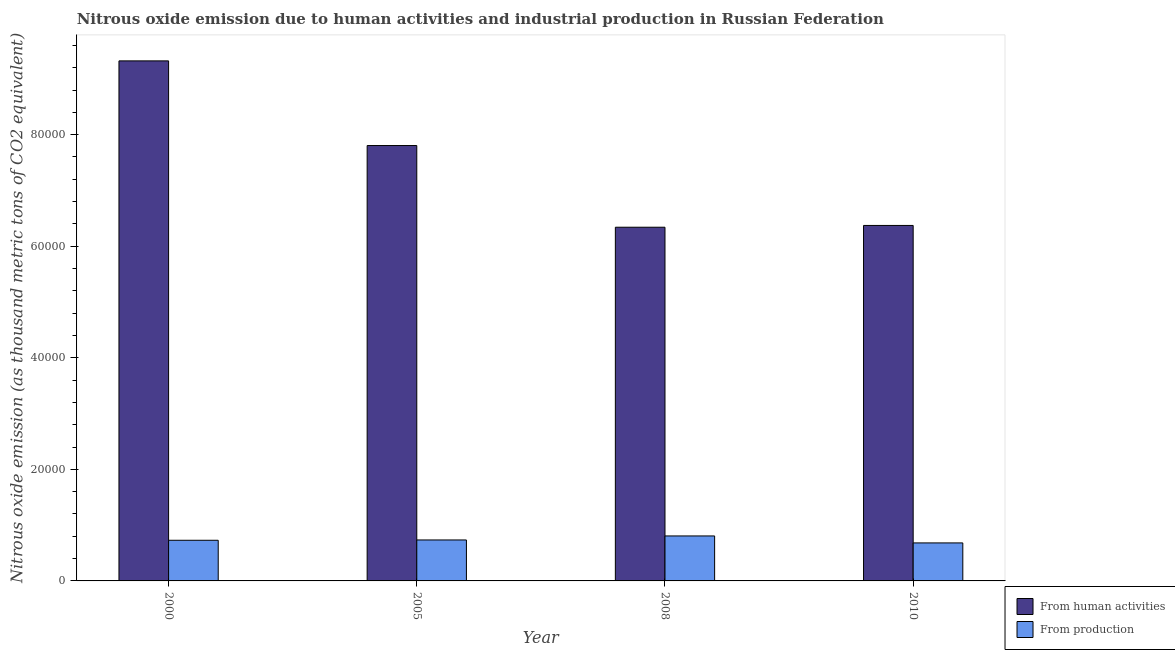How many different coloured bars are there?
Your answer should be very brief. 2. How many groups of bars are there?
Provide a short and direct response. 4. Are the number of bars per tick equal to the number of legend labels?
Provide a short and direct response. Yes. How many bars are there on the 4th tick from the left?
Offer a very short reply. 2. How many bars are there on the 3rd tick from the right?
Ensure brevity in your answer.  2. In how many cases, is the number of bars for a given year not equal to the number of legend labels?
Provide a succinct answer. 0. What is the amount of emissions from human activities in 2005?
Offer a very short reply. 7.81e+04. Across all years, what is the maximum amount of emissions generated from industries?
Give a very brief answer. 8062.7. Across all years, what is the minimum amount of emissions generated from industries?
Offer a very short reply. 6812.8. In which year was the amount of emissions from human activities minimum?
Make the answer very short. 2008. What is the total amount of emissions from human activities in the graph?
Your answer should be very brief. 2.98e+05. What is the difference between the amount of emissions from human activities in 2008 and that in 2010?
Provide a short and direct response. -319.3. What is the difference between the amount of emissions from human activities in 2008 and the amount of emissions generated from industries in 2010?
Offer a terse response. -319.3. What is the average amount of emissions from human activities per year?
Keep it short and to the point. 7.46e+04. In the year 2005, what is the difference between the amount of emissions generated from industries and amount of emissions from human activities?
Your response must be concise. 0. In how many years, is the amount of emissions generated from industries greater than 20000 thousand metric tons?
Your answer should be very brief. 0. What is the ratio of the amount of emissions generated from industries in 2008 to that in 2010?
Your response must be concise. 1.18. Is the amount of emissions from human activities in 2005 less than that in 2008?
Your answer should be compact. No. Is the difference between the amount of emissions from human activities in 2000 and 2008 greater than the difference between the amount of emissions generated from industries in 2000 and 2008?
Make the answer very short. No. What is the difference between the highest and the second highest amount of emissions generated from industries?
Give a very brief answer. 718.6. What is the difference between the highest and the lowest amount of emissions generated from industries?
Your answer should be very brief. 1249.9. In how many years, is the amount of emissions from human activities greater than the average amount of emissions from human activities taken over all years?
Ensure brevity in your answer.  2. Is the sum of the amount of emissions from human activities in 2005 and 2010 greater than the maximum amount of emissions generated from industries across all years?
Your response must be concise. Yes. What does the 1st bar from the left in 2005 represents?
Give a very brief answer. From human activities. What does the 2nd bar from the right in 2010 represents?
Your response must be concise. From human activities. How many bars are there?
Offer a terse response. 8. Are all the bars in the graph horizontal?
Provide a succinct answer. No. How many years are there in the graph?
Offer a very short reply. 4. Are the values on the major ticks of Y-axis written in scientific E-notation?
Your answer should be compact. No. Does the graph contain any zero values?
Your response must be concise. No. How are the legend labels stacked?
Give a very brief answer. Vertical. What is the title of the graph?
Offer a very short reply. Nitrous oxide emission due to human activities and industrial production in Russian Federation. What is the label or title of the X-axis?
Ensure brevity in your answer.  Year. What is the label or title of the Y-axis?
Provide a succinct answer. Nitrous oxide emission (as thousand metric tons of CO2 equivalent). What is the Nitrous oxide emission (as thousand metric tons of CO2 equivalent) of From human activities in 2000?
Provide a succinct answer. 9.32e+04. What is the Nitrous oxide emission (as thousand metric tons of CO2 equivalent) in From production in 2000?
Offer a very short reply. 7288.4. What is the Nitrous oxide emission (as thousand metric tons of CO2 equivalent) in From human activities in 2005?
Provide a succinct answer. 7.81e+04. What is the Nitrous oxide emission (as thousand metric tons of CO2 equivalent) in From production in 2005?
Offer a very short reply. 7344.1. What is the Nitrous oxide emission (as thousand metric tons of CO2 equivalent) in From human activities in 2008?
Make the answer very short. 6.34e+04. What is the Nitrous oxide emission (as thousand metric tons of CO2 equivalent) in From production in 2008?
Ensure brevity in your answer.  8062.7. What is the Nitrous oxide emission (as thousand metric tons of CO2 equivalent) in From human activities in 2010?
Provide a short and direct response. 6.37e+04. What is the Nitrous oxide emission (as thousand metric tons of CO2 equivalent) in From production in 2010?
Your response must be concise. 6812.8. Across all years, what is the maximum Nitrous oxide emission (as thousand metric tons of CO2 equivalent) of From human activities?
Provide a short and direct response. 9.32e+04. Across all years, what is the maximum Nitrous oxide emission (as thousand metric tons of CO2 equivalent) in From production?
Make the answer very short. 8062.7. Across all years, what is the minimum Nitrous oxide emission (as thousand metric tons of CO2 equivalent) of From human activities?
Ensure brevity in your answer.  6.34e+04. Across all years, what is the minimum Nitrous oxide emission (as thousand metric tons of CO2 equivalent) of From production?
Provide a short and direct response. 6812.8. What is the total Nitrous oxide emission (as thousand metric tons of CO2 equivalent) of From human activities in the graph?
Offer a terse response. 2.98e+05. What is the total Nitrous oxide emission (as thousand metric tons of CO2 equivalent) of From production in the graph?
Make the answer very short. 2.95e+04. What is the difference between the Nitrous oxide emission (as thousand metric tons of CO2 equivalent) in From human activities in 2000 and that in 2005?
Ensure brevity in your answer.  1.52e+04. What is the difference between the Nitrous oxide emission (as thousand metric tons of CO2 equivalent) of From production in 2000 and that in 2005?
Offer a terse response. -55.7. What is the difference between the Nitrous oxide emission (as thousand metric tons of CO2 equivalent) of From human activities in 2000 and that in 2008?
Offer a very short reply. 2.98e+04. What is the difference between the Nitrous oxide emission (as thousand metric tons of CO2 equivalent) of From production in 2000 and that in 2008?
Your response must be concise. -774.3. What is the difference between the Nitrous oxide emission (as thousand metric tons of CO2 equivalent) of From human activities in 2000 and that in 2010?
Your answer should be compact. 2.95e+04. What is the difference between the Nitrous oxide emission (as thousand metric tons of CO2 equivalent) in From production in 2000 and that in 2010?
Offer a very short reply. 475.6. What is the difference between the Nitrous oxide emission (as thousand metric tons of CO2 equivalent) in From human activities in 2005 and that in 2008?
Give a very brief answer. 1.46e+04. What is the difference between the Nitrous oxide emission (as thousand metric tons of CO2 equivalent) in From production in 2005 and that in 2008?
Ensure brevity in your answer.  -718.6. What is the difference between the Nitrous oxide emission (as thousand metric tons of CO2 equivalent) of From human activities in 2005 and that in 2010?
Keep it short and to the point. 1.43e+04. What is the difference between the Nitrous oxide emission (as thousand metric tons of CO2 equivalent) of From production in 2005 and that in 2010?
Provide a succinct answer. 531.3. What is the difference between the Nitrous oxide emission (as thousand metric tons of CO2 equivalent) in From human activities in 2008 and that in 2010?
Your response must be concise. -319.3. What is the difference between the Nitrous oxide emission (as thousand metric tons of CO2 equivalent) of From production in 2008 and that in 2010?
Offer a very short reply. 1249.9. What is the difference between the Nitrous oxide emission (as thousand metric tons of CO2 equivalent) in From human activities in 2000 and the Nitrous oxide emission (as thousand metric tons of CO2 equivalent) in From production in 2005?
Ensure brevity in your answer.  8.59e+04. What is the difference between the Nitrous oxide emission (as thousand metric tons of CO2 equivalent) of From human activities in 2000 and the Nitrous oxide emission (as thousand metric tons of CO2 equivalent) of From production in 2008?
Give a very brief answer. 8.52e+04. What is the difference between the Nitrous oxide emission (as thousand metric tons of CO2 equivalent) of From human activities in 2000 and the Nitrous oxide emission (as thousand metric tons of CO2 equivalent) of From production in 2010?
Provide a short and direct response. 8.64e+04. What is the difference between the Nitrous oxide emission (as thousand metric tons of CO2 equivalent) of From human activities in 2005 and the Nitrous oxide emission (as thousand metric tons of CO2 equivalent) of From production in 2008?
Give a very brief answer. 7.00e+04. What is the difference between the Nitrous oxide emission (as thousand metric tons of CO2 equivalent) in From human activities in 2005 and the Nitrous oxide emission (as thousand metric tons of CO2 equivalent) in From production in 2010?
Offer a very short reply. 7.12e+04. What is the difference between the Nitrous oxide emission (as thousand metric tons of CO2 equivalent) of From human activities in 2008 and the Nitrous oxide emission (as thousand metric tons of CO2 equivalent) of From production in 2010?
Your response must be concise. 5.66e+04. What is the average Nitrous oxide emission (as thousand metric tons of CO2 equivalent) of From human activities per year?
Ensure brevity in your answer.  7.46e+04. What is the average Nitrous oxide emission (as thousand metric tons of CO2 equivalent) in From production per year?
Your answer should be compact. 7377. In the year 2000, what is the difference between the Nitrous oxide emission (as thousand metric tons of CO2 equivalent) of From human activities and Nitrous oxide emission (as thousand metric tons of CO2 equivalent) of From production?
Offer a very short reply. 8.59e+04. In the year 2005, what is the difference between the Nitrous oxide emission (as thousand metric tons of CO2 equivalent) in From human activities and Nitrous oxide emission (as thousand metric tons of CO2 equivalent) in From production?
Offer a very short reply. 7.07e+04. In the year 2008, what is the difference between the Nitrous oxide emission (as thousand metric tons of CO2 equivalent) in From human activities and Nitrous oxide emission (as thousand metric tons of CO2 equivalent) in From production?
Your answer should be compact. 5.53e+04. In the year 2010, what is the difference between the Nitrous oxide emission (as thousand metric tons of CO2 equivalent) of From human activities and Nitrous oxide emission (as thousand metric tons of CO2 equivalent) of From production?
Keep it short and to the point. 5.69e+04. What is the ratio of the Nitrous oxide emission (as thousand metric tons of CO2 equivalent) in From human activities in 2000 to that in 2005?
Provide a short and direct response. 1.19. What is the ratio of the Nitrous oxide emission (as thousand metric tons of CO2 equivalent) in From production in 2000 to that in 2005?
Offer a terse response. 0.99. What is the ratio of the Nitrous oxide emission (as thousand metric tons of CO2 equivalent) of From human activities in 2000 to that in 2008?
Your answer should be compact. 1.47. What is the ratio of the Nitrous oxide emission (as thousand metric tons of CO2 equivalent) in From production in 2000 to that in 2008?
Offer a terse response. 0.9. What is the ratio of the Nitrous oxide emission (as thousand metric tons of CO2 equivalent) in From human activities in 2000 to that in 2010?
Your answer should be compact. 1.46. What is the ratio of the Nitrous oxide emission (as thousand metric tons of CO2 equivalent) in From production in 2000 to that in 2010?
Provide a succinct answer. 1.07. What is the ratio of the Nitrous oxide emission (as thousand metric tons of CO2 equivalent) of From human activities in 2005 to that in 2008?
Make the answer very short. 1.23. What is the ratio of the Nitrous oxide emission (as thousand metric tons of CO2 equivalent) of From production in 2005 to that in 2008?
Make the answer very short. 0.91. What is the ratio of the Nitrous oxide emission (as thousand metric tons of CO2 equivalent) in From human activities in 2005 to that in 2010?
Provide a succinct answer. 1.22. What is the ratio of the Nitrous oxide emission (as thousand metric tons of CO2 equivalent) of From production in 2005 to that in 2010?
Provide a succinct answer. 1.08. What is the ratio of the Nitrous oxide emission (as thousand metric tons of CO2 equivalent) in From production in 2008 to that in 2010?
Give a very brief answer. 1.18. What is the difference between the highest and the second highest Nitrous oxide emission (as thousand metric tons of CO2 equivalent) of From human activities?
Provide a succinct answer. 1.52e+04. What is the difference between the highest and the second highest Nitrous oxide emission (as thousand metric tons of CO2 equivalent) of From production?
Your response must be concise. 718.6. What is the difference between the highest and the lowest Nitrous oxide emission (as thousand metric tons of CO2 equivalent) in From human activities?
Keep it short and to the point. 2.98e+04. What is the difference between the highest and the lowest Nitrous oxide emission (as thousand metric tons of CO2 equivalent) in From production?
Provide a short and direct response. 1249.9. 